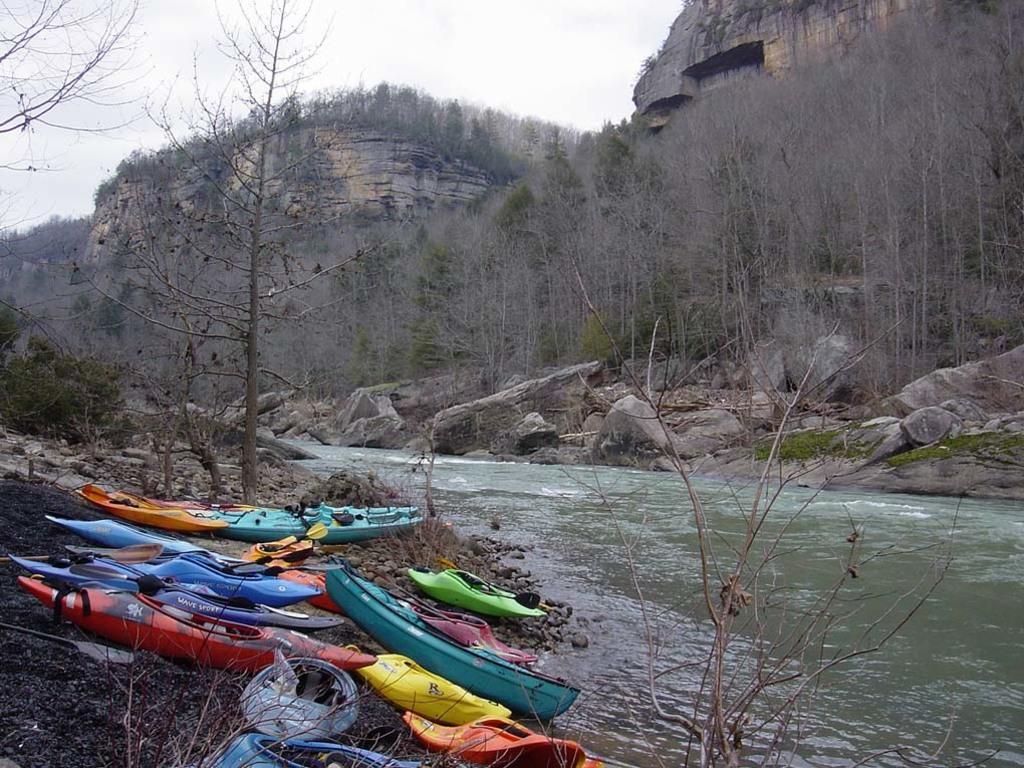Please provide a concise description of this image. In this image we can see water, boats on the ground, few trees, stones, mountains and the sky in the background. 